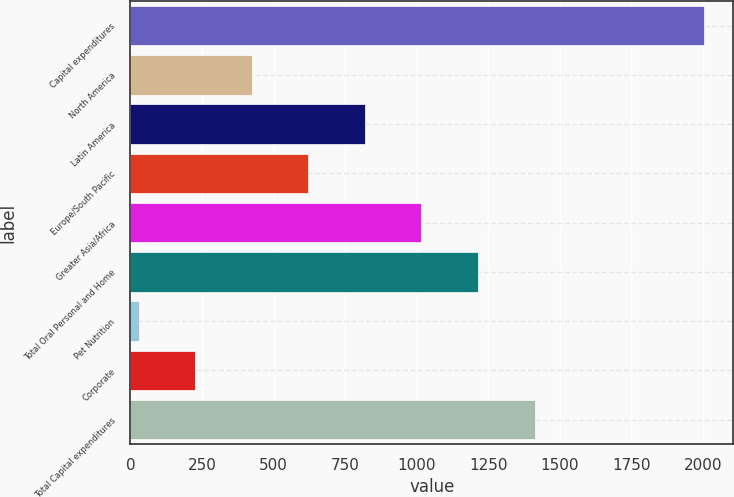Convert chart to OTSL. <chart><loc_0><loc_0><loc_500><loc_500><bar_chart><fcel>Capital expenditures<fcel>North America<fcel>Latin America<fcel>Europe/South Pacific<fcel>Greater Asia/Africa<fcel>Total Oral Personal and Home<fcel>Pet Nutrition<fcel>Corporate<fcel>Total Capital expenditures<nl><fcel>2005<fcel>423.8<fcel>819.1<fcel>621.45<fcel>1016.75<fcel>1214.4<fcel>28.5<fcel>226.15<fcel>1412.05<nl></chart> 